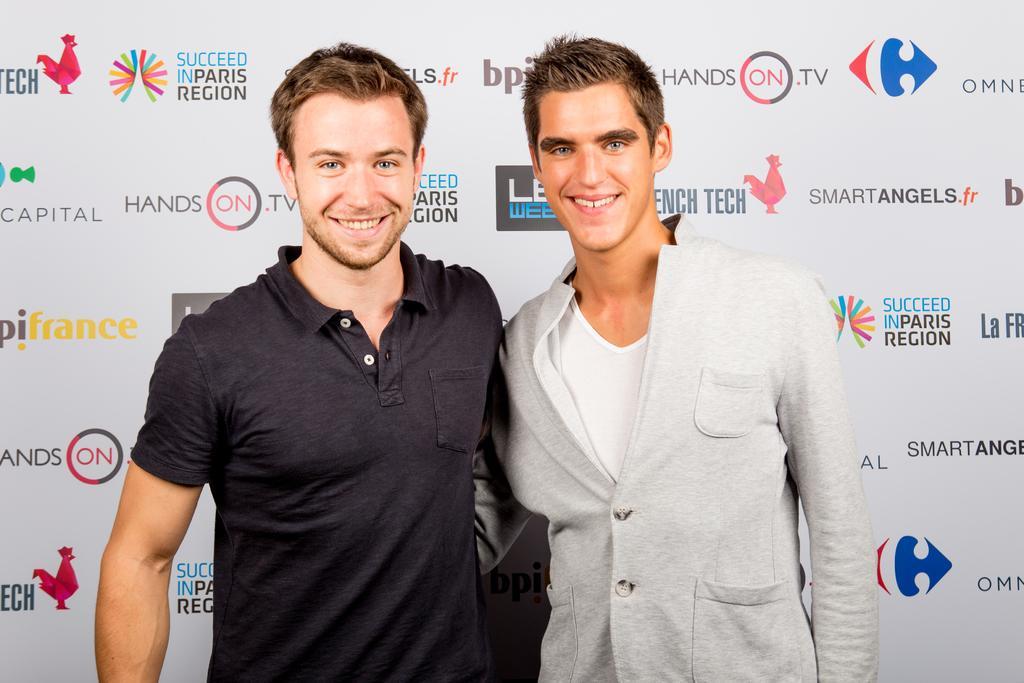In one or two sentences, can you explain what this image depicts? In this image we can see two people. In the background of the image there is banner with some text. 